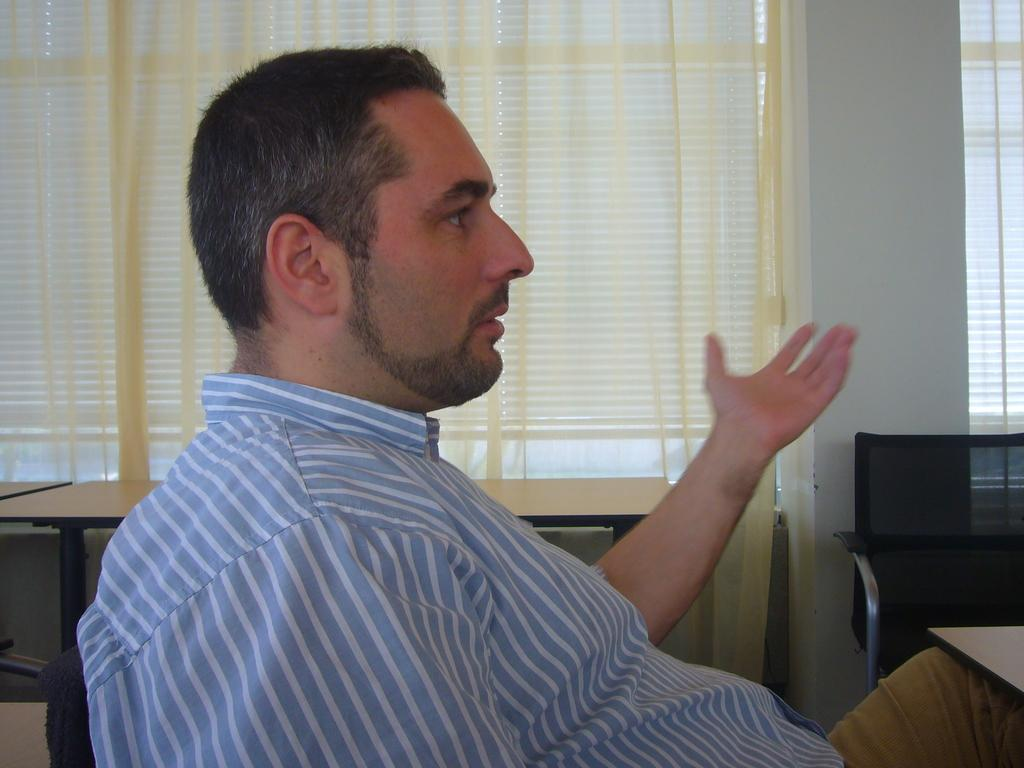Who is present in the image? There is a man in the image. What is the man doing in the image? The man is sitting on a chair. What is the man wearing on his upper body? The man is wearing a blue and white color shirt. What is the man wearing on his lower body? The man is wearing cream color pants. What trick is the man performing with the apparatus in the image? There is no apparatus or trick present in the image; the man is simply sitting on a chair wearing a blue and white color shirt and cream color pants. 